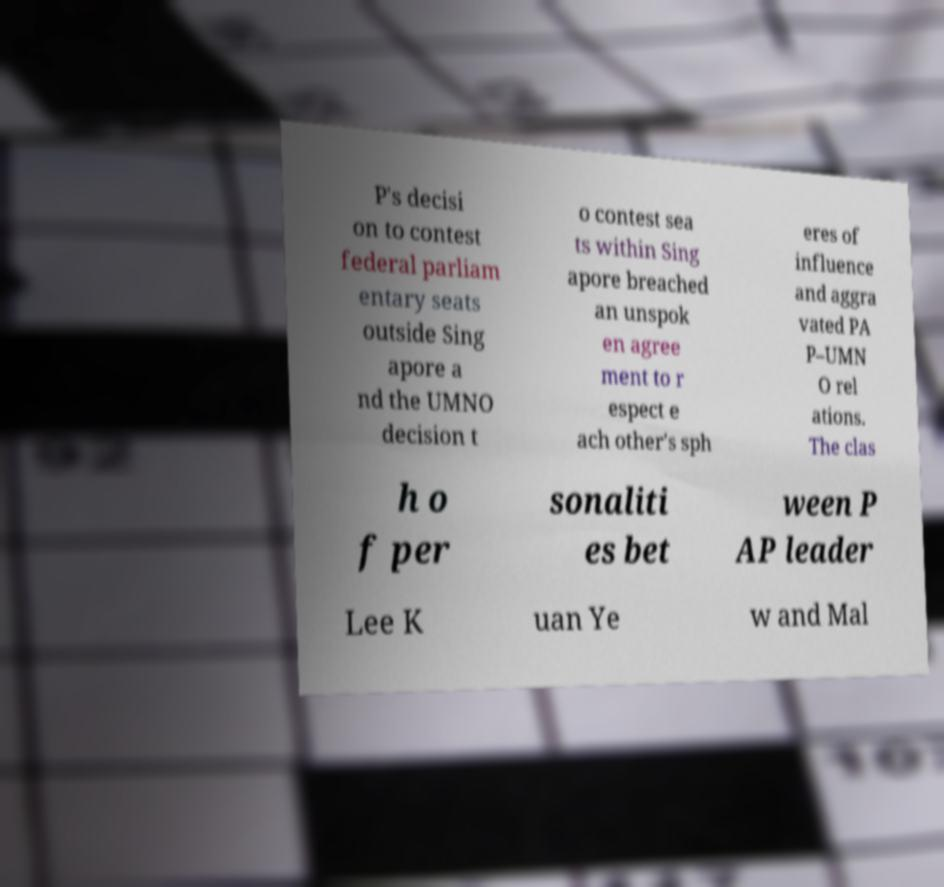What messages or text are displayed in this image? I need them in a readable, typed format. P's decisi on to contest federal parliam entary seats outside Sing apore a nd the UMNO decision t o contest sea ts within Sing apore breached an unspok en agree ment to r espect e ach other's sph eres of influence and aggra vated PA P–UMN O rel ations. The clas h o f per sonaliti es bet ween P AP leader Lee K uan Ye w and Mal 